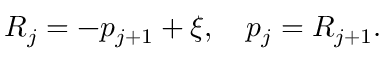Convert formula to latex. <formula><loc_0><loc_0><loc_500><loc_500>R _ { j } = - p _ { j + 1 } + \xi , p _ { j } = R _ { j + 1 } .</formula> 